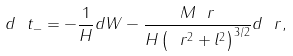<formula> <loc_0><loc_0><loc_500><loc_500>d \ t _ { - } = - \frac { 1 } { H } d W - \frac { M \ r } { H \left ( \ r ^ { 2 } + l ^ { 2 } \right ) ^ { 3 / 2 } } d \ r ,</formula> 